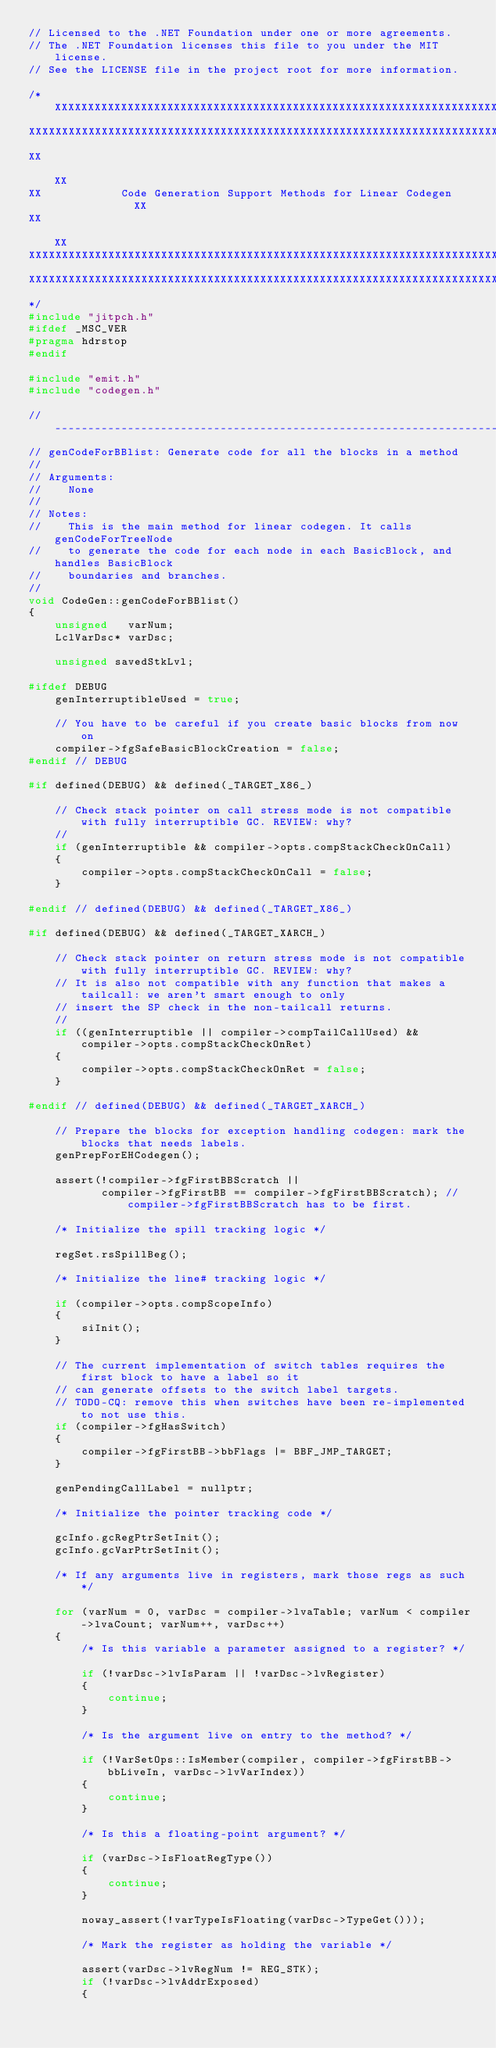<code> <loc_0><loc_0><loc_500><loc_500><_C++_>// Licensed to the .NET Foundation under one or more agreements.
// The .NET Foundation licenses this file to you under the MIT license.
// See the LICENSE file in the project root for more information.

/*XXXXXXXXXXXXXXXXXXXXXXXXXXXXXXXXXXXXXXXXXXXXXXXXXXXXXXXXXXXXXXXXXXXXXXXXXXXXX
XXXXXXXXXXXXXXXXXXXXXXXXXXXXXXXXXXXXXXXXXXXXXXXXXXXXXXXXXXXXXXXXXXXXXXXXXXXXXXX
XX                                                                           XX
XX            Code Generation Support Methods for Linear Codegen             XX
XX                                                                           XX
XXXXXXXXXXXXXXXXXXXXXXXXXXXXXXXXXXXXXXXXXXXXXXXXXXXXXXXXXXXXXXXXXXXXXXXXXXXXXXX
XXXXXXXXXXXXXXXXXXXXXXXXXXXXXXXXXXXXXXXXXXXXXXXXXXXXXXXXXXXXXXXXXXXXXXXXXXXXXXX
*/
#include "jitpch.h"
#ifdef _MSC_VER
#pragma hdrstop
#endif

#include "emit.h"
#include "codegen.h"

//------------------------------------------------------------------------
// genCodeForBBlist: Generate code for all the blocks in a method
//
// Arguments:
//    None
//
// Notes:
//    This is the main method for linear codegen. It calls genCodeForTreeNode
//    to generate the code for each node in each BasicBlock, and handles BasicBlock
//    boundaries and branches.
//
void CodeGen::genCodeForBBlist()
{
    unsigned   varNum;
    LclVarDsc* varDsc;

    unsigned savedStkLvl;

#ifdef DEBUG
    genInterruptibleUsed = true;

    // You have to be careful if you create basic blocks from now on
    compiler->fgSafeBasicBlockCreation = false;
#endif // DEBUG

#if defined(DEBUG) && defined(_TARGET_X86_)

    // Check stack pointer on call stress mode is not compatible with fully interruptible GC. REVIEW: why?
    //
    if (genInterruptible && compiler->opts.compStackCheckOnCall)
    {
        compiler->opts.compStackCheckOnCall = false;
    }

#endif // defined(DEBUG) && defined(_TARGET_X86_)

#if defined(DEBUG) && defined(_TARGET_XARCH_)

    // Check stack pointer on return stress mode is not compatible with fully interruptible GC. REVIEW: why?
    // It is also not compatible with any function that makes a tailcall: we aren't smart enough to only
    // insert the SP check in the non-tailcall returns.
    //
    if ((genInterruptible || compiler->compTailCallUsed) && compiler->opts.compStackCheckOnRet)
    {
        compiler->opts.compStackCheckOnRet = false;
    }

#endif // defined(DEBUG) && defined(_TARGET_XARCH_)

    // Prepare the blocks for exception handling codegen: mark the blocks that needs labels.
    genPrepForEHCodegen();

    assert(!compiler->fgFirstBBScratch ||
           compiler->fgFirstBB == compiler->fgFirstBBScratch); // compiler->fgFirstBBScratch has to be first.

    /* Initialize the spill tracking logic */

    regSet.rsSpillBeg();

    /* Initialize the line# tracking logic */

    if (compiler->opts.compScopeInfo)
    {
        siInit();
    }

    // The current implementation of switch tables requires the first block to have a label so it
    // can generate offsets to the switch label targets.
    // TODO-CQ: remove this when switches have been re-implemented to not use this.
    if (compiler->fgHasSwitch)
    {
        compiler->fgFirstBB->bbFlags |= BBF_JMP_TARGET;
    }

    genPendingCallLabel = nullptr;

    /* Initialize the pointer tracking code */

    gcInfo.gcRegPtrSetInit();
    gcInfo.gcVarPtrSetInit();

    /* If any arguments live in registers, mark those regs as such */

    for (varNum = 0, varDsc = compiler->lvaTable; varNum < compiler->lvaCount; varNum++, varDsc++)
    {
        /* Is this variable a parameter assigned to a register? */

        if (!varDsc->lvIsParam || !varDsc->lvRegister)
        {
            continue;
        }

        /* Is the argument live on entry to the method? */

        if (!VarSetOps::IsMember(compiler, compiler->fgFirstBB->bbLiveIn, varDsc->lvVarIndex))
        {
            continue;
        }

        /* Is this a floating-point argument? */

        if (varDsc->IsFloatRegType())
        {
            continue;
        }

        noway_assert(!varTypeIsFloating(varDsc->TypeGet()));

        /* Mark the register as holding the variable */

        assert(varDsc->lvRegNum != REG_STK);
        if (!varDsc->lvAddrExposed)
        {</code> 